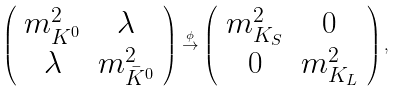Convert formula to latex. <formula><loc_0><loc_0><loc_500><loc_500>\left ( \begin{array} { c c } m ^ { 2 } _ { K ^ { 0 } } & \lambda \\ \lambda & m ^ { 2 } _ { \bar { K } ^ { 0 } } \end{array} \right ) \stackrel { \phi } { \rightarrow } \left ( \begin{array} { c c } m ^ { 2 } _ { K _ { S } } & 0 \\ 0 & m ^ { 2 } _ { K _ { L } } \end{array} \right ) ,</formula> 